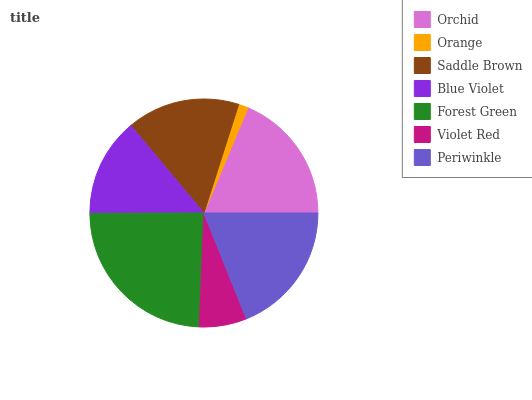Is Orange the minimum?
Answer yes or no. Yes. Is Forest Green the maximum?
Answer yes or no. Yes. Is Saddle Brown the minimum?
Answer yes or no. No. Is Saddle Brown the maximum?
Answer yes or no. No. Is Saddle Brown greater than Orange?
Answer yes or no. Yes. Is Orange less than Saddle Brown?
Answer yes or no. Yes. Is Orange greater than Saddle Brown?
Answer yes or no. No. Is Saddle Brown less than Orange?
Answer yes or no. No. Is Saddle Brown the high median?
Answer yes or no. Yes. Is Saddle Brown the low median?
Answer yes or no. Yes. Is Periwinkle the high median?
Answer yes or no. No. Is Orchid the low median?
Answer yes or no. No. 